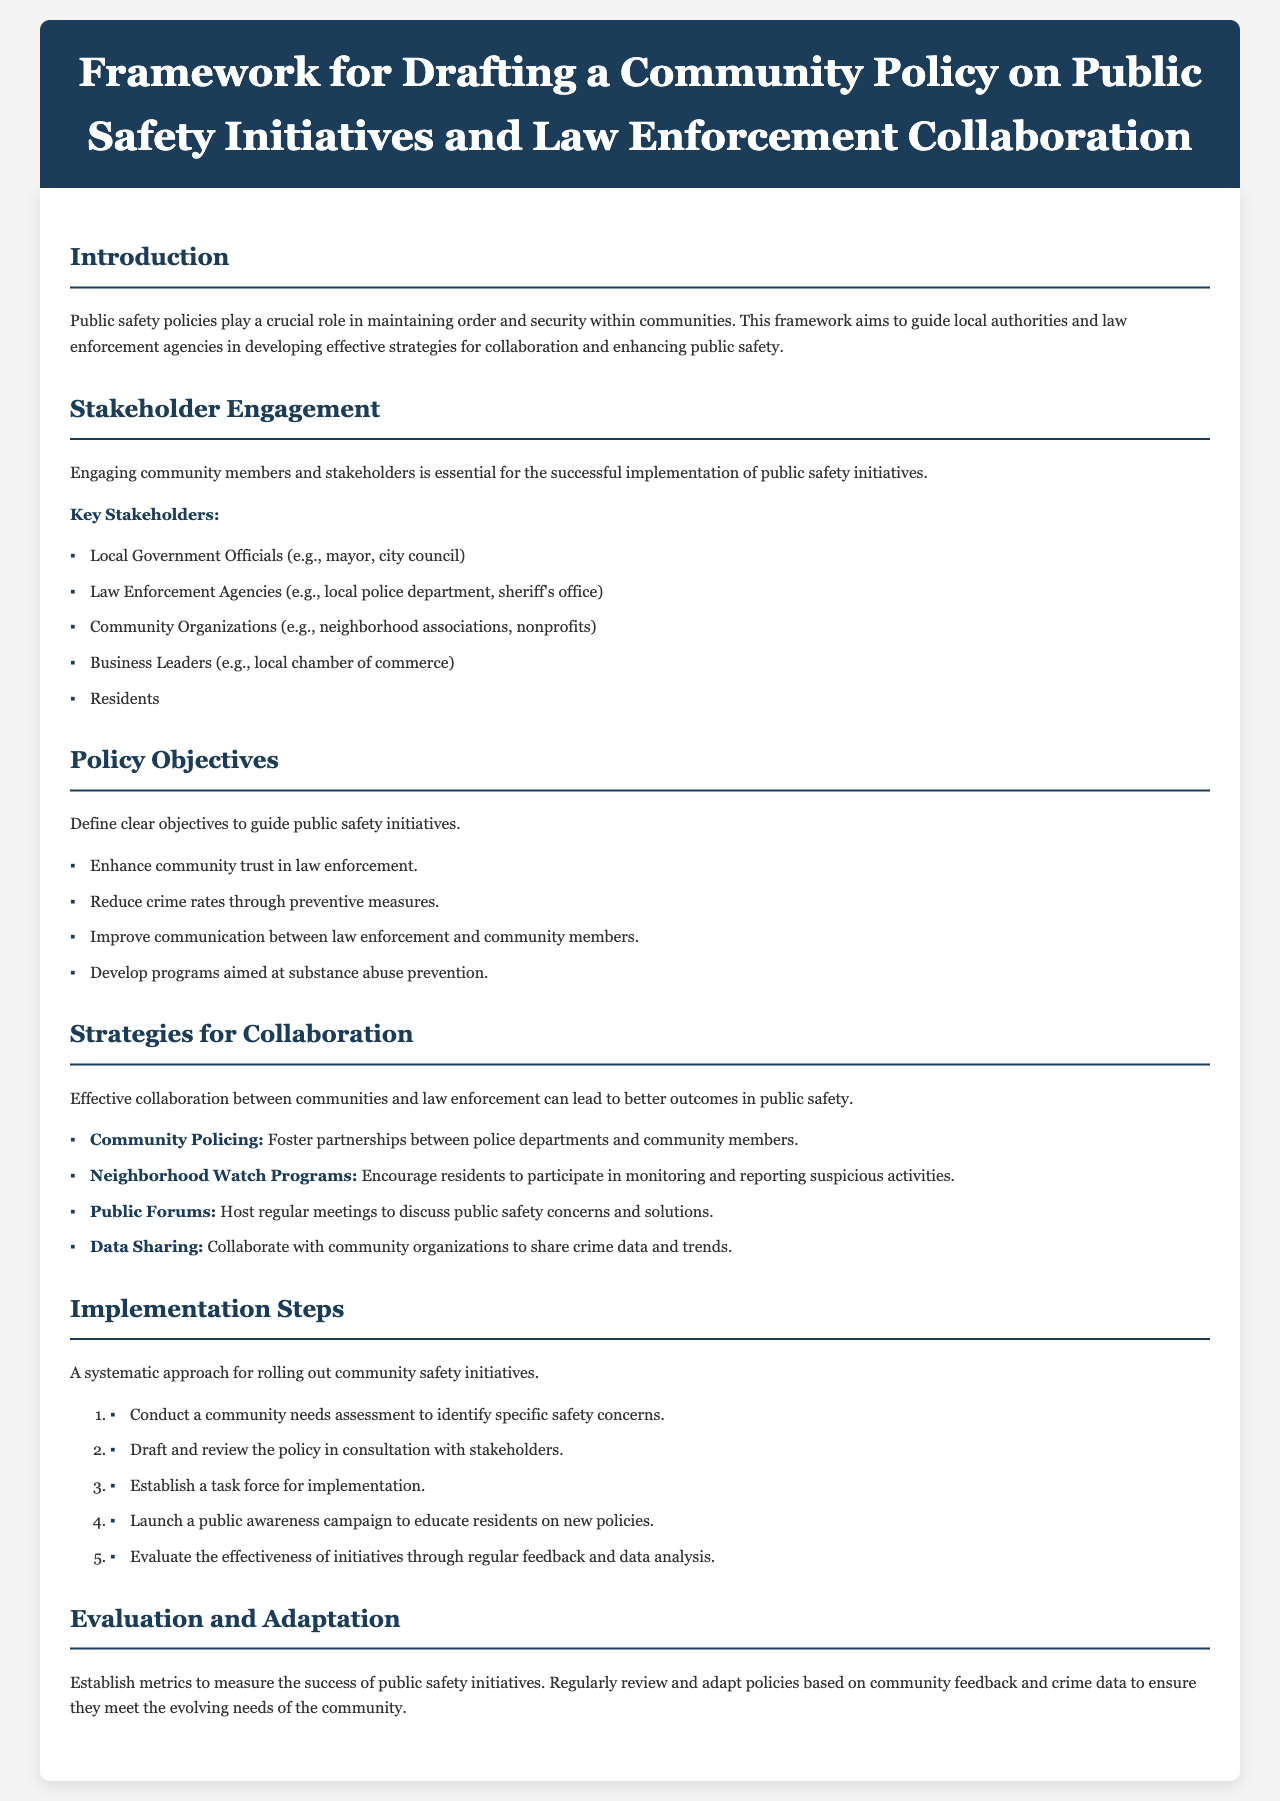What is the main purpose of the framework? The framework aims to guide local authorities and law enforcement agencies in developing effective strategies for collaboration and enhancing public safety.
Answer: Enhance public safety Who are considered key stakeholders in public safety initiatives? Key stakeholders include various groups like government officials, law enforcement agencies, and community organizations listed in the document.
Answer: Local Government Officials, Law Enforcement Agencies, Community Organizations, Business Leaders, Residents How many policy objectives are defined in the document? The document lists four clear policy objectives that guide public safety initiatives.
Answer: Four What is one strategy mentioned for fostering collaboration? The document provides several strategies; one of them specifically mentioned is community policing.
Answer: Community Policing What is the first step in the implementation process? The document outlines steps for implementation, starting with a community needs assessment.
Answer: Conduct a community needs assessment What does the document emphasize about evaluation and adaptation? It notes the importance of establishing metrics and regularly reviewing and adapting policies based on community needs.
Answer: Establish metrics What type of meetings does the framework suggest hosting to discuss public safety concerns? The document mentions public forums as a method to gather community feedback and concerns about safety.
Answer: Public Forums How many steps are in the implementation process? The implementation process consists of five systematic steps described in the framework.
Answer: Five 